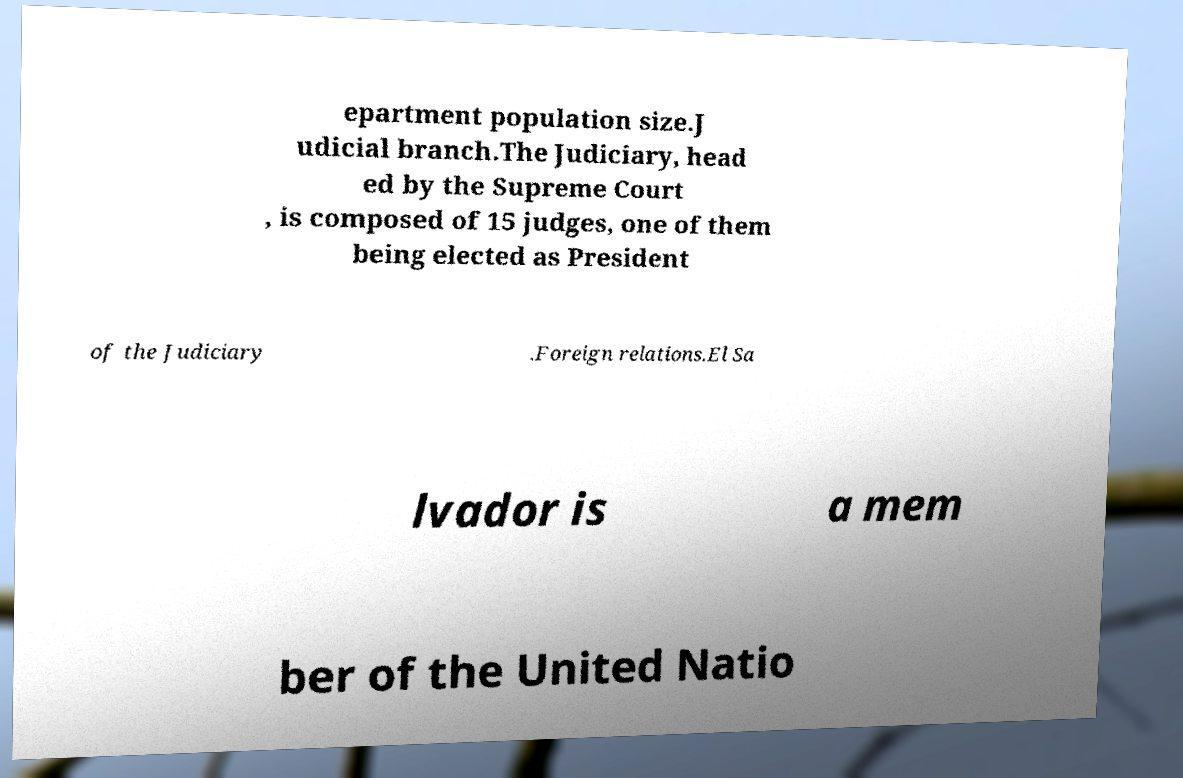There's text embedded in this image that I need extracted. Can you transcribe it verbatim? epartment population size.J udicial branch.The Judiciary, head ed by the Supreme Court , is composed of 15 judges, one of them being elected as President of the Judiciary .Foreign relations.El Sa lvador is a mem ber of the United Natio 